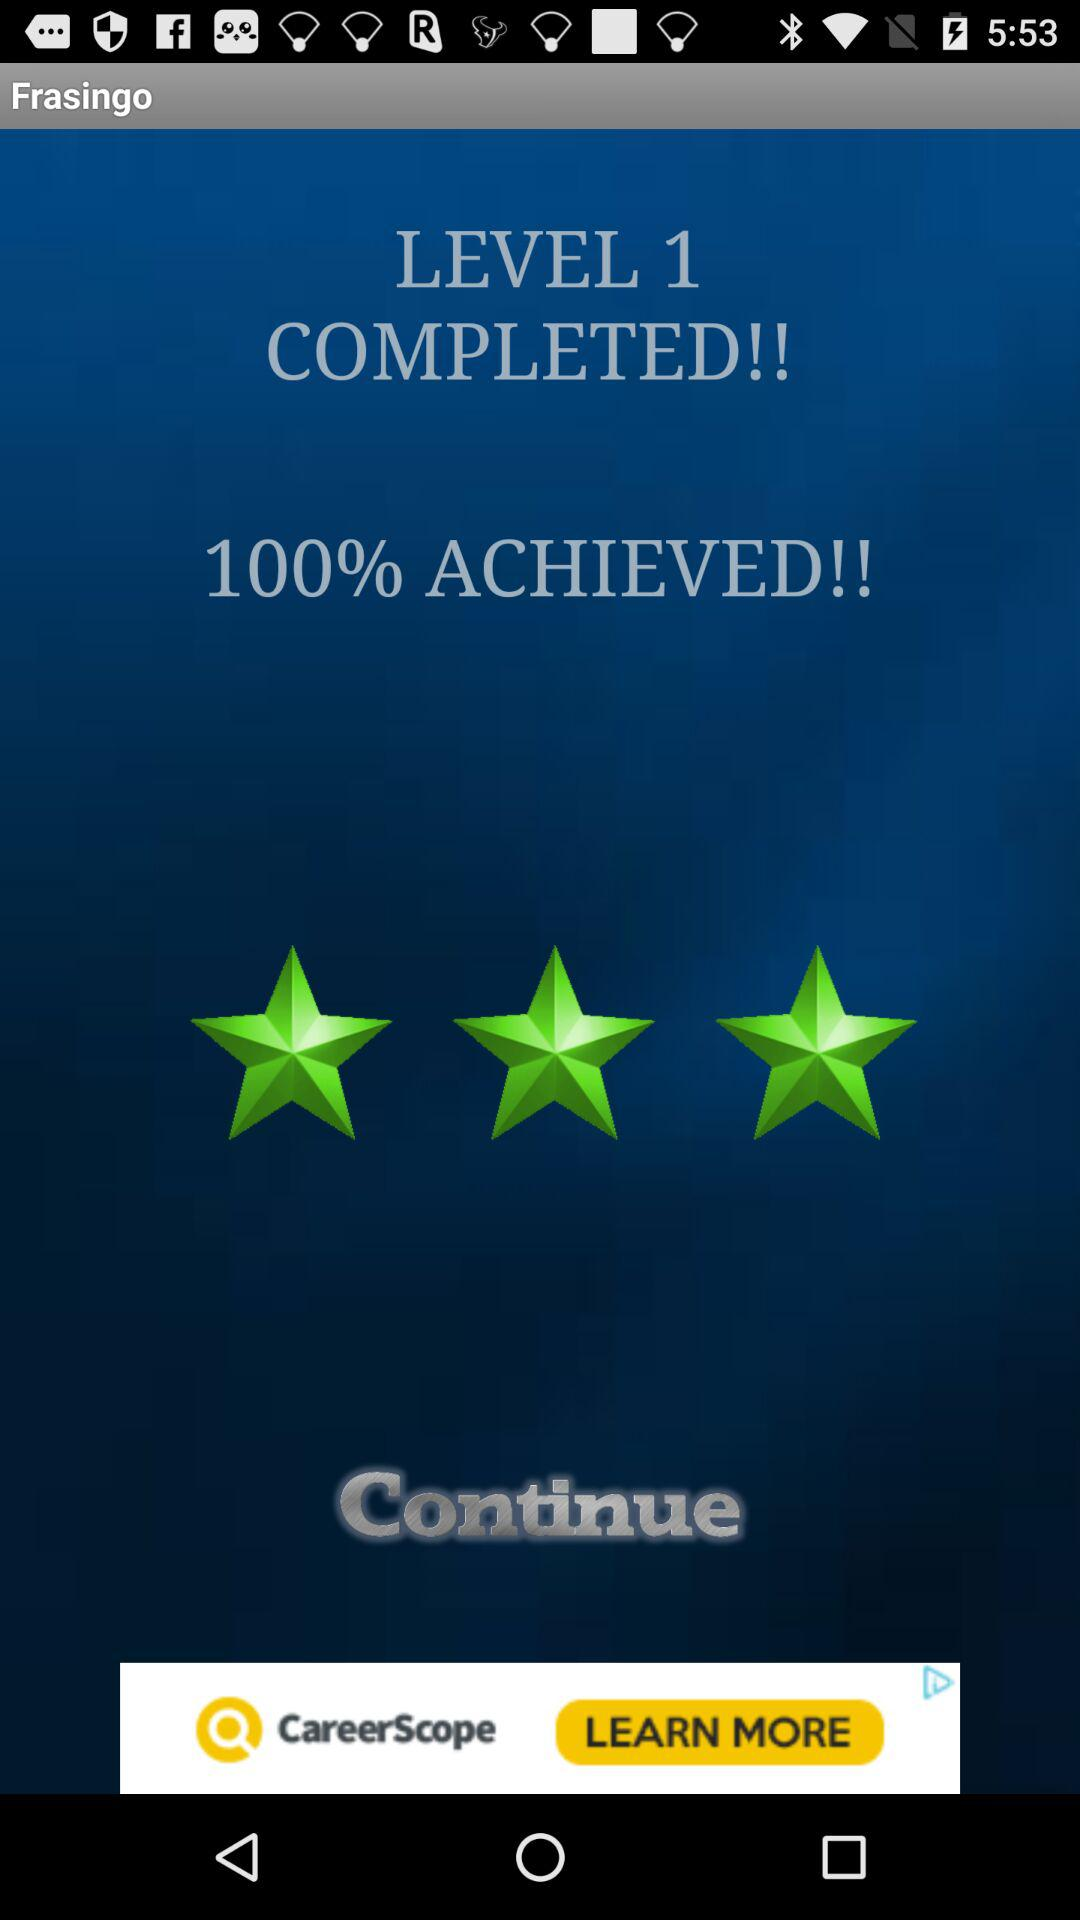What is the app name? The app name is "Frasingo". 